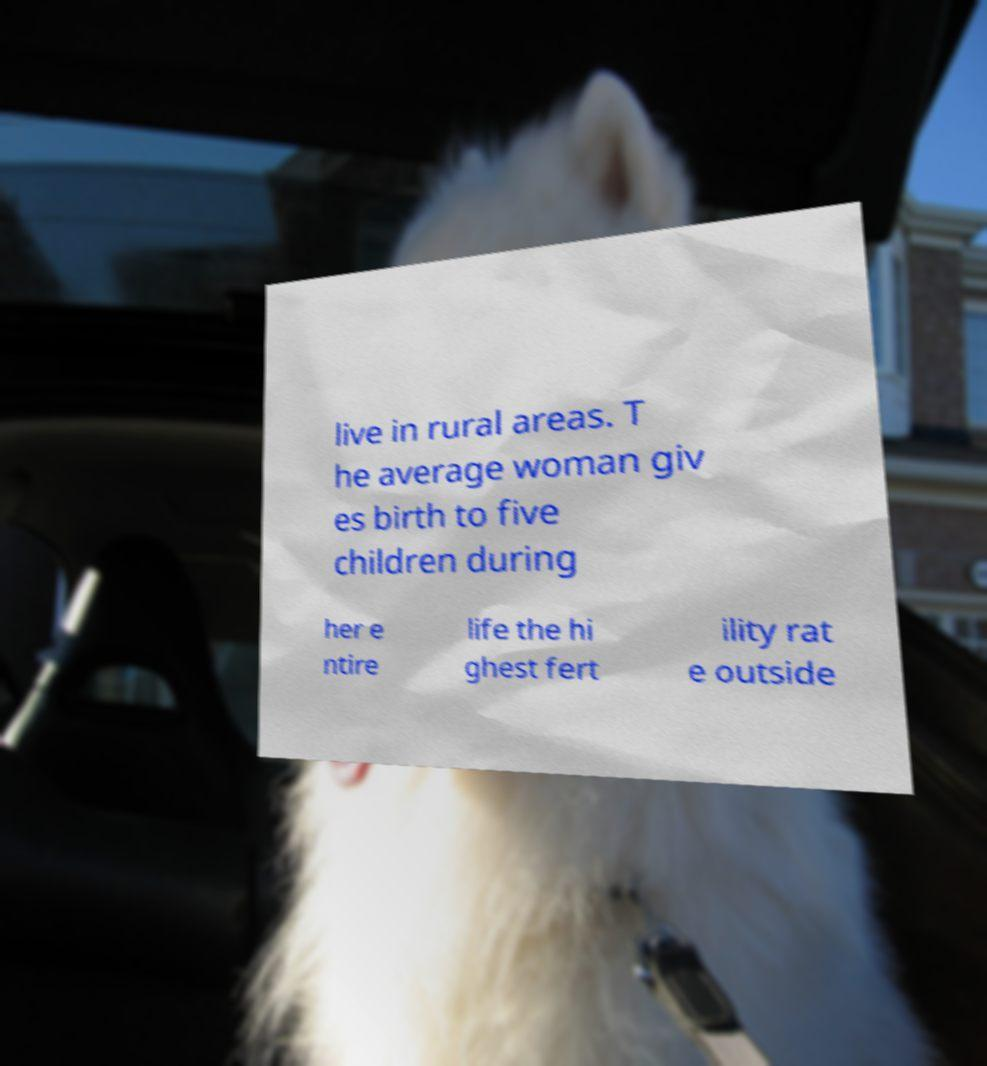I need the written content from this picture converted into text. Can you do that? live in rural areas. T he average woman giv es birth to five children during her e ntire life the hi ghest fert ility rat e outside 